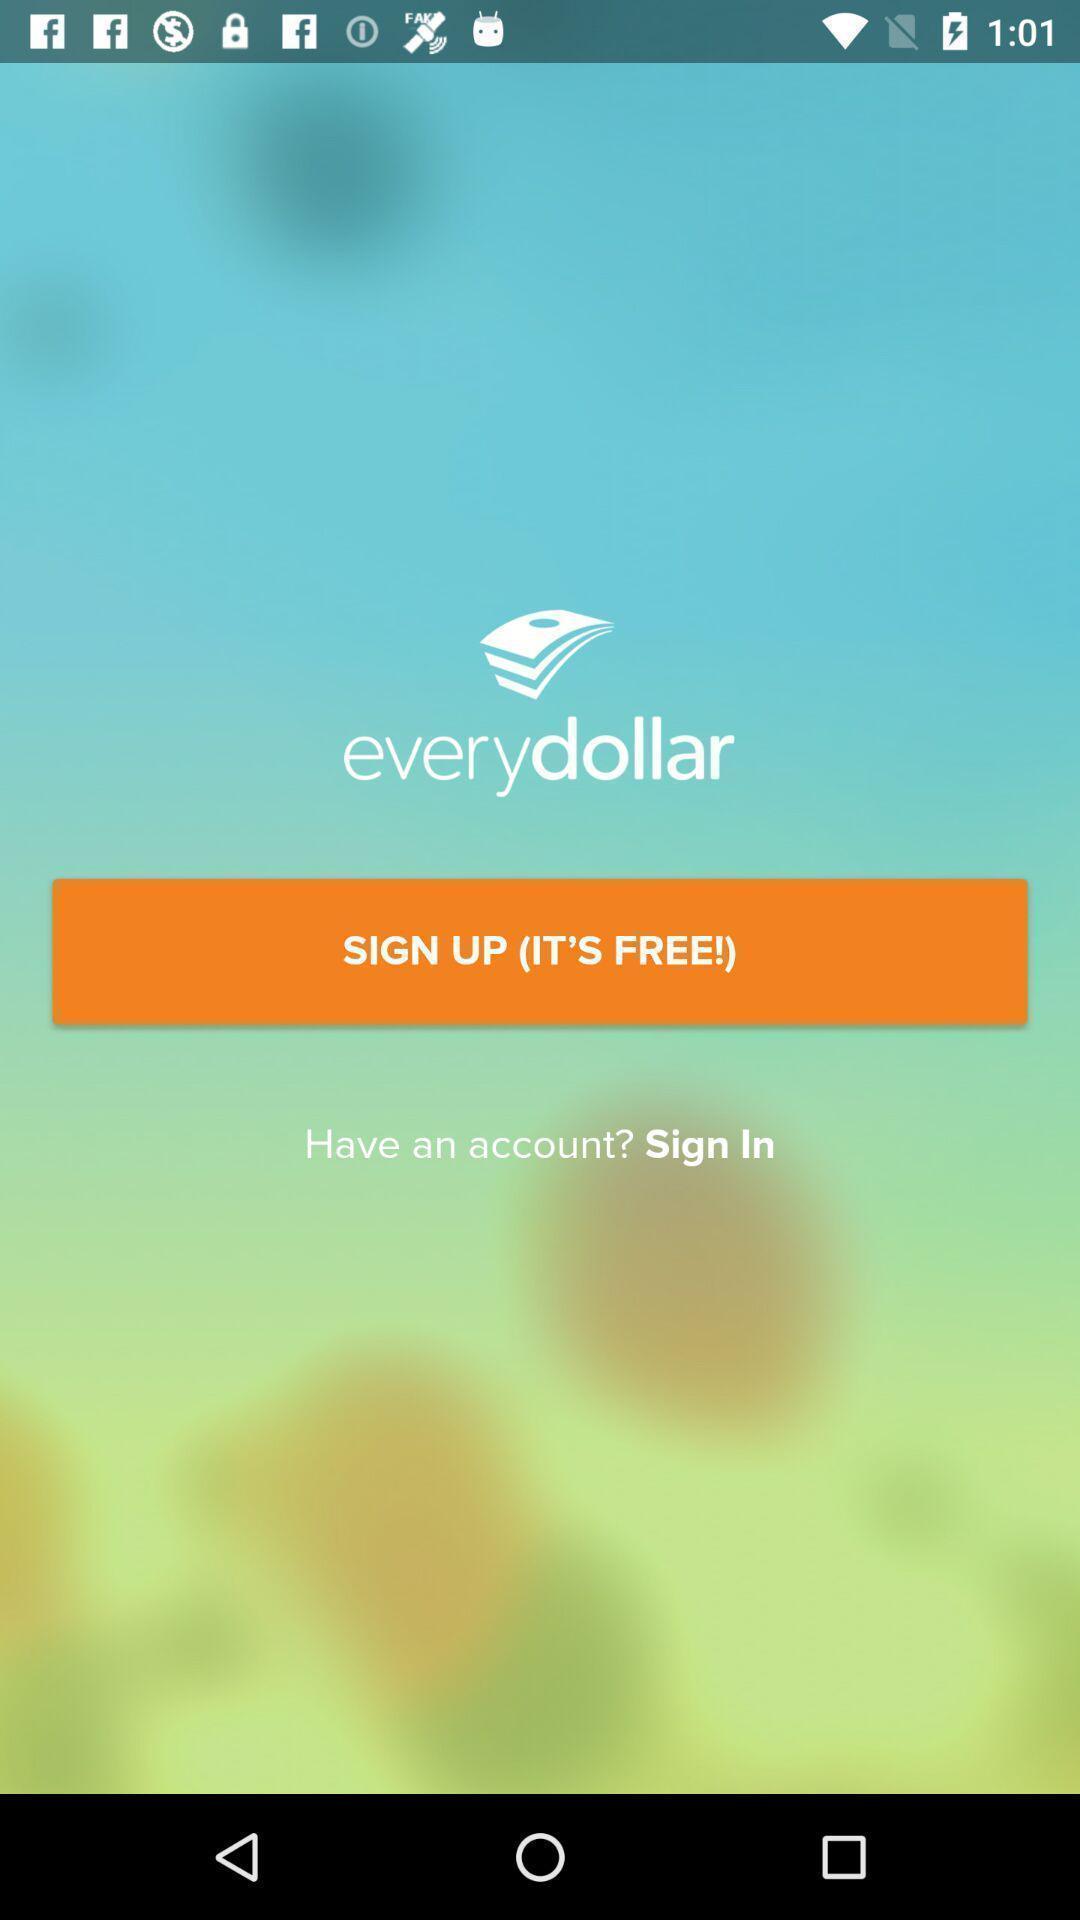Provide a detailed account of this screenshot. Welcome page in a finance app. 